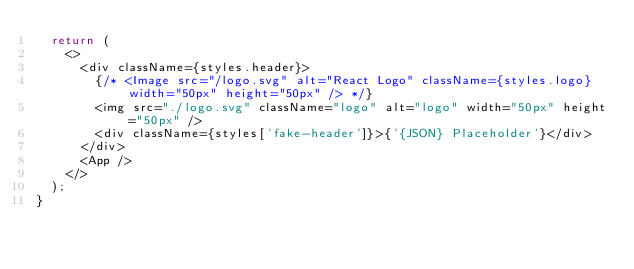<code> <loc_0><loc_0><loc_500><loc_500><_JavaScript_>  return (
    <>
      <div className={styles.header}>
        {/* <Image src="/logo.svg" alt="React Logo" className={styles.logo} width="50px" height="50px" /> */}
        <img src="./logo.svg" className="logo" alt="logo" width="50px" height="50px" />
        <div className={styles['fake-header']}>{'{JSON} Placeholder'}</div>
      </div>
      <App />
    </>
  );
}
</code> 